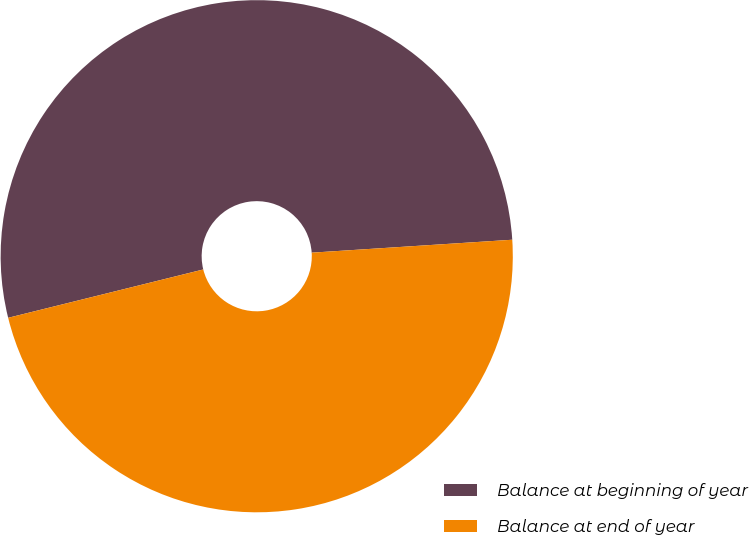Convert chart to OTSL. <chart><loc_0><loc_0><loc_500><loc_500><pie_chart><fcel>Balance at beginning of year<fcel>Balance at end of year<nl><fcel>52.84%<fcel>47.16%<nl></chart> 